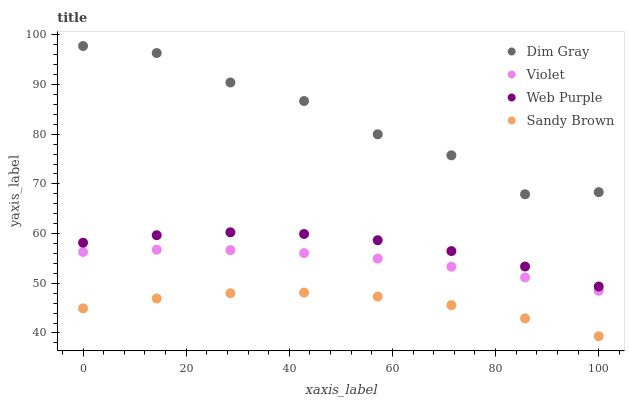Does Sandy Brown have the minimum area under the curve?
Answer yes or no. Yes. Does Dim Gray have the maximum area under the curve?
Answer yes or no. Yes. Does Dim Gray have the minimum area under the curve?
Answer yes or no. No. Does Sandy Brown have the maximum area under the curve?
Answer yes or no. No. Is Violet the smoothest?
Answer yes or no. Yes. Is Dim Gray the roughest?
Answer yes or no. Yes. Is Sandy Brown the smoothest?
Answer yes or no. No. Is Sandy Brown the roughest?
Answer yes or no. No. Does Sandy Brown have the lowest value?
Answer yes or no. Yes. Does Dim Gray have the lowest value?
Answer yes or no. No. Does Dim Gray have the highest value?
Answer yes or no. Yes. Does Sandy Brown have the highest value?
Answer yes or no. No. Is Violet less than Dim Gray?
Answer yes or no. Yes. Is Dim Gray greater than Web Purple?
Answer yes or no. Yes. Does Violet intersect Dim Gray?
Answer yes or no. No. 